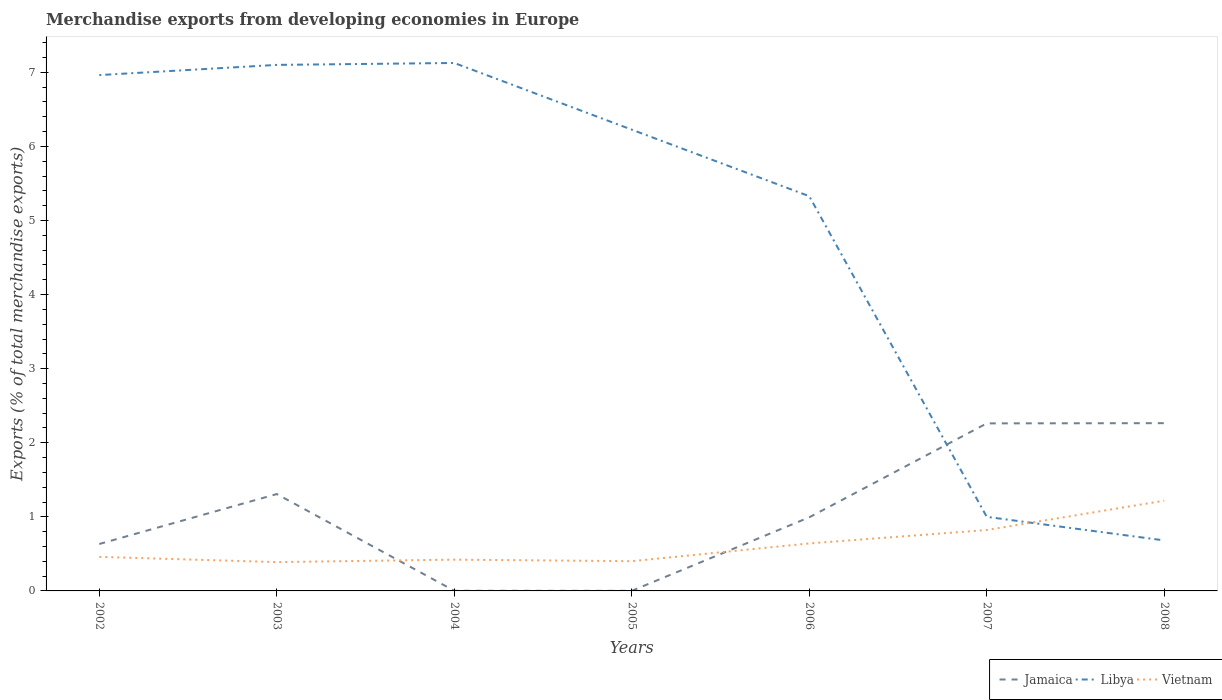How many different coloured lines are there?
Offer a terse response. 3. Does the line corresponding to Jamaica intersect with the line corresponding to Vietnam?
Make the answer very short. Yes. Is the number of lines equal to the number of legend labels?
Your answer should be compact. Yes. Across all years, what is the maximum percentage of total merchandise exports in Jamaica?
Your response must be concise. 0. What is the total percentage of total merchandise exports in Vietnam in the graph?
Your answer should be very brief. -0.18. What is the difference between the highest and the second highest percentage of total merchandise exports in Libya?
Provide a succinct answer. 6.44. Is the percentage of total merchandise exports in Vietnam strictly greater than the percentage of total merchandise exports in Jamaica over the years?
Offer a very short reply. No. How many years are there in the graph?
Provide a short and direct response. 7. What is the difference between two consecutive major ticks on the Y-axis?
Your response must be concise. 1. Does the graph contain any zero values?
Ensure brevity in your answer.  No. How many legend labels are there?
Keep it short and to the point. 3. How are the legend labels stacked?
Your response must be concise. Horizontal. What is the title of the graph?
Your answer should be very brief. Merchandise exports from developing economies in Europe. Does "Uganda" appear as one of the legend labels in the graph?
Your response must be concise. No. What is the label or title of the X-axis?
Offer a very short reply. Years. What is the label or title of the Y-axis?
Offer a terse response. Exports (% of total merchandise exports). What is the Exports (% of total merchandise exports) of Jamaica in 2002?
Provide a short and direct response. 0.63. What is the Exports (% of total merchandise exports) of Libya in 2002?
Your answer should be very brief. 6.96. What is the Exports (% of total merchandise exports) of Vietnam in 2002?
Offer a very short reply. 0.46. What is the Exports (% of total merchandise exports) of Jamaica in 2003?
Ensure brevity in your answer.  1.31. What is the Exports (% of total merchandise exports) in Libya in 2003?
Offer a very short reply. 7.1. What is the Exports (% of total merchandise exports) of Vietnam in 2003?
Offer a very short reply. 0.39. What is the Exports (% of total merchandise exports) of Jamaica in 2004?
Provide a short and direct response. 0. What is the Exports (% of total merchandise exports) of Libya in 2004?
Provide a succinct answer. 7.13. What is the Exports (% of total merchandise exports) in Vietnam in 2004?
Provide a short and direct response. 0.42. What is the Exports (% of total merchandise exports) of Jamaica in 2005?
Give a very brief answer. 0. What is the Exports (% of total merchandise exports) of Libya in 2005?
Make the answer very short. 6.23. What is the Exports (% of total merchandise exports) of Vietnam in 2005?
Provide a short and direct response. 0.4. What is the Exports (% of total merchandise exports) in Jamaica in 2006?
Offer a terse response. 0.99. What is the Exports (% of total merchandise exports) of Libya in 2006?
Offer a terse response. 5.33. What is the Exports (% of total merchandise exports) in Vietnam in 2006?
Your answer should be compact. 0.64. What is the Exports (% of total merchandise exports) in Jamaica in 2007?
Offer a very short reply. 2.26. What is the Exports (% of total merchandise exports) of Libya in 2007?
Give a very brief answer. 1. What is the Exports (% of total merchandise exports) in Vietnam in 2007?
Offer a very short reply. 0.82. What is the Exports (% of total merchandise exports) of Jamaica in 2008?
Make the answer very short. 2.26. What is the Exports (% of total merchandise exports) in Libya in 2008?
Make the answer very short. 0.68. What is the Exports (% of total merchandise exports) in Vietnam in 2008?
Make the answer very short. 1.22. Across all years, what is the maximum Exports (% of total merchandise exports) in Jamaica?
Your response must be concise. 2.26. Across all years, what is the maximum Exports (% of total merchandise exports) in Libya?
Give a very brief answer. 7.13. Across all years, what is the maximum Exports (% of total merchandise exports) of Vietnam?
Provide a succinct answer. 1.22. Across all years, what is the minimum Exports (% of total merchandise exports) of Jamaica?
Keep it short and to the point. 0. Across all years, what is the minimum Exports (% of total merchandise exports) of Libya?
Your answer should be compact. 0.68. Across all years, what is the minimum Exports (% of total merchandise exports) in Vietnam?
Ensure brevity in your answer.  0.39. What is the total Exports (% of total merchandise exports) of Jamaica in the graph?
Offer a very short reply. 7.46. What is the total Exports (% of total merchandise exports) in Libya in the graph?
Keep it short and to the point. 34.42. What is the total Exports (% of total merchandise exports) of Vietnam in the graph?
Your answer should be compact. 4.35. What is the difference between the Exports (% of total merchandise exports) in Jamaica in 2002 and that in 2003?
Give a very brief answer. -0.67. What is the difference between the Exports (% of total merchandise exports) of Libya in 2002 and that in 2003?
Offer a terse response. -0.14. What is the difference between the Exports (% of total merchandise exports) in Vietnam in 2002 and that in 2003?
Provide a succinct answer. 0.07. What is the difference between the Exports (% of total merchandise exports) of Jamaica in 2002 and that in 2004?
Your response must be concise. 0.63. What is the difference between the Exports (% of total merchandise exports) of Libya in 2002 and that in 2004?
Your answer should be very brief. -0.16. What is the difference between the Exports (% of total merchandise exports) in Vietnam in 2002 and that in 2004?
Make the answer very short. 0.04. What is the difference between the Exports (% of total merchandise exports) in Jamaica in 2002 and that in 2005?
Your answer should be very brief. 0.63. What is the difference between the Exports (% of total merchandise exports) in Libya in 2002 and that in 2005?
Ensure brevity in your answer.  0.74. What is the difference between the Exports (% of total merchandise exports) in Vietnam in 2002 and that in 2005?
Provide a succinct answer. 0.06. What is the difference between the Exports (% of total merchandise exports) of Jamaica in 2002 and that in 2006?
Your answer should be very brief. -0.36. What is the difference between the Exports (% of total merchandise exports) in Libya in 2002 and that in 2006?
Offer a very short reply. 1.63. What is the difference between the Exports (% of total merchandise exports) in Vietnam in 2002 and that in 2006?
Your response must be concise. -0.18. What is the difference between the Exports (% of total merchandise exports) of Jamaica in 2002 and that in 2007?
Keep it short and to the point. -1.63. What is the difference between the Exports (% of total merchandise exports) of Libya in 2002 and that in 2007?
Give a very brief answer. 5.96. What is the difference between the Exports (% of total merchandise exports) in Vietnam in 2002 and that in 2007?
Offer a very short reply. -0.36. What is the difference between the Exports (% of total merchandise exports) of Jamaica in 2002 and that in 2008?
Keep it short and to the point. -1.63. What is the difference between the Exports (% of total merchandise exports) in Libya in 2002 and that in 2008?
Offer a terse response. 6.28. What is the difference between the Exports (% of total merchandise exports) of Vietnam in 2002 and that in 2008?
Ensure brevity in your answer.  -0.76. What is the difference between the Exports (% of total merchandise exports) of Jamaica in 2003 and that in 2004?
Your answer should be compact. 1.31. What is the difference between the Exports (% of total merchandise exports) of Libya in 2003 and that in 2004?
Provide a short and direct response. -0.03. What is the difference between the Exports (% of total merchandise exports) in Vietnam in 2003 and that in 2004?
Offer a terse response. -0.03. What is the difference between the Exports (% of total merchandise exports) of Jamaica in 2003 and that in 2005?
Provide a succinct answer. 1.31. What is the difference between the Exports (% of total merchandise exports) of Libya in 2003 and that in 2005?
Make the answer very short. 0.87. What is the difference between the Exports (% of total merchandise exports) in Vietnam in 2003 and that in 2005?
Provide a short and direct response. -0.01. What is the difference between the Exports (% of total merchandise exports) of Jamaica in 2003 and that in 2006?
Offer a very short reply. 0.31. What is the difference between the Exports (% of total merchandise exports) of Libya in 2003 and that in 2006?
Your answer should be very brief. 1.77. What is the difference between the Exports (% of total merchandise exports) of Vietnam in 2003 and that in 2006?
Keep it short and to the point. -0.25. What is the difference between the Exports (% of total merchandise exports) in Jamaica in 2003 and that in 2007?
Offer a very short reply. -0.95. What is the difference between the Exports (% of total merchandise exports) of Libya in 2003 and that in 2007?
Make the answer very short. 6.1. What is the difference between the Exports (% of total merchandise exports) of Vietnam in 2003 and that in 2007?
Give a very brief answer. -0.43. What is the difference between the Exports (% of total merchandise exports) in Jamaica in 2003 and that in 2008?
Your answer should be compact. -0.96. What is the difference between the Exports (% of total merchandise exports) in Libya in 2003 and that in 2008?
Keep it short and to the point. 6.42. What is the difference between the Exports (% of total merchandise exports) of Vietnam in 2003 and that in 2008?
Your answer should be very brief. -0.83. What is the difference between the Exports (% of total merchandise exports) of Jamaica in 2004 and that in 2005?
Your response must be concise. 0. What is the difference between the Exports (% of total merchandise exports) of Libya in 2004 and that in 2005?
Keep it short and to the point. 0.9. What is the difference between the Exports (% of total merchandise exports) in Vietnam in 2004 and that in 2005?
Keep it short and to the point. 0.02. What is the difference between the Exports (% of total merchandise exports) of Jamaica in 2004 and that in 2006?
Ensure brevity in your answer.  -0.99. What is the difference between the Exports (% of total merchandise exports) of Libya in 2004 and that in 2006?
Offer a very short reply. 1.8. What is the difference between the Exports (% of total merchandise exports) of Vietnam in 2004 and that in 2006?
Keep it short and to the point. -0.22. What is the difference between the Exports (% of total merchandise exports) of Jamaica in 2004 and that in 2007?
Your answer should be compact. -2.26. What is the difference between the Exports (% of total merchandise exports) of Libya in 2004 and that in 2007?
Provide a succinct answer. 6.13. What is the difference between the Exports (% of total merchandise exports) in Vietnam in 2004 and that in 2007?
Your answer should be compact. -0.4. What is the difference between the Exports (% of total merchandise exports) in Jamaica in 2004 and that in 2008?
Give a very brief answer. -2.26. What is the difference between the Exports (% of total merchandise exports) in Libya in 2004 and that in 2008?
Your response must be concise. 6.44. What is the difference between the Exports (% of total merchandise exports) in Vietnam in 2004 and that in 2008?
Offer a terse response. -0.8. What is the difference between the Exports (% of total merchandise exports) of Jamaica in 2005 and that in 2006?
Make the answer very short. -0.99. What is the difference between the Exports (% of total merchandise exports) of Libya in 2005 and that in 2006?
Provide a short and direct response. 0.9. What is the difference between the Exports (% of total merchandise exports) of Vietnam in 2005 and that in 2006?
Keep it short and to the point. -0.24. What is the difference between the Exports (% of total merchandise exports) of Jamaica in 2005 and that in 2007?
Make the answer very short. -2.26. What is the difference between the Exports (% of total merchandise exports) in Libya in 2005 and that in 2007?
Provide a succinct answer. 5.23. What is the difference between the Exports (% of total merchandise exports) in Vietnam in 2005 and that in 2007?
Give a very brief answer. -0.42. What is the difference between the Exports (% of total merchandise exports) in Jamaica in 2005 and that in 2008?
Your answer should be compact. -2.26. What is the difference between the Exports (% of total merchandise exports) in Libya in 2005 and that in 2008?
Ensure brevity in your answer.  5.54. What is the difference between the Exports (% of total merchandise exports) of Vietnam in 2005 and that in 2008?
Provide a succinct answer. -0.82. What is the difference between the Exports (% of total merchandise exports) of Jamaica in 2006 and that in 2007?
Offer a very short reply. -1.27. What is the difference between the Exports (% of total merchandise exports) in Libya in 2006 and that in 2007?
Your answer should be compact. 4.33. What is the difference between the Exports (% of total merchandise exports) in Vietnam in 2006 and that in 2007?
Offer a terse response. -0.18. What is the difference between the Exports (% of total merchandise exports) of Jamaica in 2006 and that in 2008?
Provide a succinct answer. -1.27. What is the difference between the Exports (% of total merchandise exports) of Libya in 2006 and that in 2008?
Keep it short and to the point. 4.65. What is the difference between the Exports (% of total merchandise exports) of Vietnam in 2006 and that in 2008?
Offer a very short reply. -0.58. What is the difference between the Exports (% of total merchandise exports) of Jamaica in 2007 and that in 2008?
Ensure brevity in your answer.  -0. What is the difference between the Exports (% of total merchandise exports) of Libya in 2007 and that in 2008?
Give a very brief answer. 0.32. What is the difference between the Exports (% of total merchandise exports) of Vietnam in 2007 and that in 2008?
Ensure brevity in your answer.  -0.4. What is the difference between the Exports (% of total merchandise exports) of Jamaica in 2002 and the Exports (% of total merchandise exports) of Libya in 2003?
Offer a terse response. -6.47. What is the difference between the Exports (% of total merchandise exports) of Jamaica in 2002 and the Exports (% of total merchandise exports) of Vietnam in 2003?
Your response must be concise. 0.24. What is the difference between the Exports (% of total merchandise exports) in Libya in 2002 and the Exports (% of total merchandise exports) in Vietnam in 2003?
Ensure brevity in your answer.  6.57. What is the difference between the Exports (% of total merchandise exports) of Jamaica in 2002 and the Exports (% of total merchandise exports) of Libya in 2004?
Give a very brief answer. -6.49. What is the difference between the Exports (% of total merchandise exports) in Jamaica in 2002 and the Exports (% of total merchandise exports) in Vietnam in 2004?
Your answer should be compact. 0.21. What is the difference between the Exports (% of total merchandise exports) in Libya in 2002 and the Exports (% of total merchandise exports) in Vietnam in 2004?
Provide a succinct answer. 6.54. What is the difference between the Exports (% of total merchandise exports) in Jamaica in 2002 and the Exports (% of total merchandise exports) in Libya in 2005?
Offer a terse response. -5.59. What is the difference between the Exports (% of total merchandise exports) of Jamaica in 2002 and the Exports (% of total merchandise exports) of Vietnam in 2005?
Provide a succinct answer. 0.23. What is the difference between the Exports (% of total merchandise exports) of Libya in 2002 and the Exports (% of total merchandise exports) of Vietnam in 2005?
Provide a succinct answer. 6.56. What is the difference between the Exports (% of total merchandise exports) of Jamaica in 2002 and the Exports (% of total merchandise exports) of Libya in 2006?
Keep it short and to the point. -4.69. What is the difference between the Exports (% of total merchandise exports) of Jamaica in 2002 and the Exports (% of total merchandise exports) of Vietnam in 2006?
Your answer should be compact. -0.01. What is the difference between the Exports (% of total merchandise exports) in Libya in 2002 and the Exports (% of total merchandise exports) in Vietnam in 2006?
Keep it short and to the point. 6.32. What is the difference between the Exports (% of total merchandise exports) in Jamaica in 2002 and the Exports (% of total merchandise exports) in Libya in 2007?
Provide a succinct answer. -0.37. What is the difference between the Exports (% of total merchandise exports) in Jamaica in 2002 and the Exports (% of total merchandise exports) in Vietnam in 2007?
Your response must be concise. -0.19. What is the difference between the Exports (% of total merchandise exports) in Libya in 2002 and the Exports (% of total merchandise exports) in Vietnam in 2007?
Offer a very short reply. 6.14. What is the difference between the Exports (% of total merchandise exports) of Jamaica in 2002 and the Exports (% of total merchandise exports) of Libya in 2008?
Ensure brevity in your answer.  -0.05. What is the difference between the Exports (% of total merchandise exports) of Jamaica in 2002 and the Exports (% of total merchandise exports) of Vietnam in 2008?
Offer a very short reply. -0.58. What is the difference between the Exports (% of total merchandise exports) in Libya in 2002 and the Exports (% of total merchandise exports) in Vietnam in 2008?
Ensure brevity in your answer.  5.74. What is the difference between the Exports (% of total merchandise exports) in Jamaica in 2003 and the Exports (% of total merchandise exports) in Libya in 2004?
Ensure brevity in your answer.  -5.82. What is the difference between the Exports (% of total merchandise exports) in Jamaica in 2003 and the Exports (% of total merchandise exports) in Vietnam in 2004?
Provide a succinct answer. 0.89. What is the difference between the Exports (% of total merchandise exports) of Libya in 2003 and the Exports (% of total merchandise exports) of Vietnam in 2004?
Provide a short and direct response. 6.68. What is the difference between the Exports (% of total merchandise exports) in Jamaica in 2003 and the Exports (% of total merchandise exports) in Libya in 2005?
Provide a short and direct response. -4.92. What is the difference between the Exports (% of total merchandise exports) in Jamaica in 2003 and the Exports (% of total merchandise exports) in Vietnam in 2005?
Your response must be concise. 0.91. What is the difference between the Exports (% of total merchandise exports) of Libya in 2003 and the Exports (% of total merchandise exports) of Vietnam in 2005?
Your answer should be compact. 6.7. What is the difference between the Exports (% of total merchandise exports) in Jamaica in 2003 and the Exports (% of total merchandise exports) in Libya in 2006?
Provide a short and direct response. -4.02. What is the difference between the Exports (% of total merchandise exports) of Jamaica in 2003 and the Exports (% of total merchandise exports) of Vietnam in 2006?
Provide a succinct answer. 0.67. What is the difference between the Exports (% of total merchandise exports) of Libya in 2003 and the Exports (% of total merchandise exports) of Vietnam in 2006?
Keep it short and to the point. 6.46. What is the difference between the Exports (% of total merchandise exports) of Jamaica in 2003 and the Exports (% of total merchandise exports) of Libya in 2007?
Your answer should be compact. 0.31. What is the difference between the Exports (% of total merchandise exports) of Jamaica in 2003 and the Exports (% of total merchandise exports) of Vietnam in 2007?
Your response must be concise. 0.49. What is the difference between the Exports (% of total merchandise exports) in Libya in 2003 and the Exports (% of total merchandise exports) in Vietnam in 2007?
Ensure brevity in your answer.  6.28. What is the difference between the Exports (% of total merchandise exports) of Jamaica in 2003 and the Exports (% of total merchandise exports) of Libya in 2008?
Make the answer very short. 0.63. What is the difference between the Exports (% of total merchandise exports) in Jamaica in 2003 and the Exports (% of total merchandise exports) in Vietnam in 2008?
Give a very brief answer. 0.09. What is the difference between the Exports (% of total merchandise exports) of Libya in 2003 and the Exports (% of total merchandise exports) of Vietnam in 2008?
Ensure brevity in your answer.  5.88. What is the difference between the Exports (% of total merchandise exports) in Jamaica in 2004 and the Exports (% of total merchandise exports) in Libya in 2005?
Offer a very short reply. -6.22. What is the difference between the Exports (% of total merchandise exports) in Jamaica in 2004 and the Exports (% of total merchandise exports) in Vietnam in 2005?
Offer a terse response. -0.4. What is the difference between the Exports (% of total merchandise exports) in Libya in 2004 and the Exports (% of total merchandise exports) in Vietnam in 2005?
Provide a short and direct response. 6.72. What is the difference between the Exports (% of total merchandise exports) of Jamaica in 2004 and the Exports (% of total merchandise exports) of Libya in 2006?
Offer a terse response. -5.33. What is the difference between the Exports (% of total merchandise exports) in Jamaica in 2004 and the Exports (% of total merchandise exports) in Vietnam in 2006?
Offer a terse response. -0.64. What is the difference between the Exports (% of total merchandise exports) in Libya in 2004 and the Exports (% of total merchandise exports) in Vietnam in 2006?
Offer a very short reply. 6.48. What is the difference between the Exports (% of total merchandise exports) in Jamaica in 2004 and the Exports (% of total merchandise exports) in Libya in 2007?
Make the answer very short. -1. What is the difference between the Exports (% of total merchandise exports) of Jamaica in 2004 and the Exports (% of total merchandise exports) of Vietnam in 2007?
Your answer should be very brief. -0.82. What is the difference between the Exports (% of total merchandise exports) of Libya in 2004 and the Exports (% of total merchandise exports) of Vietnam in 2007?
Provide a short and direct response. 6.3. What is the difference between the Exports (% of total merchandise exports) in Jamaica in 2004 and the Exports (% of total merchandise exports) in Libya in 2008?
Offer a terse response. -0.68. What is the difference between the Exports (% of total merchandise exports) in Jamaica in 2004 and the Exports (% of total merchandise exports) in Vietnam in 2008?
Ensure brevity in your answer.  -1.22. What is the difference between the Exports (% of total merchandise exports) in Libya in 2004 and the Exports (% of total merchandise exports) in Vietnam in 2008?
Make the answer very short. 5.91. What is the difference between the Exports (% of total merchandise exports) of Jamaica in 2005 and the Exports (% of total merchandise exports) of Libya in 2006?
Offer a terse response. -5.33. What is the difference between the Exports (% of total merchandise exports) in Jamaica in 2005 and the Exports (% of total merchandise exports) in Vietnam in 2006?
Ensure brevity in your answer.  -0.64. What is the difference between the Exports (% of total merchandise exports) in Libya in 2005 and the Exports (% of total merchandise exports) in Vietnam in 2006?
Offer a very short reply. 5.58. What is the difference between the Exports (% of total merchandise exports) in Jamaica in 2005 and the Exports (% of total merchandise exports) in Libya in 2007?
Keep it short and to the point. -1. What is the difference between the Exports (% of total merchandise exports) of Jamaica in 2005 and the Exports (% of total merchandise exports) of Vietnam in 2007?
Your answer should be very brief. -0.82. What is the difference between the Exports (% of total merchandise exports) of Libya in 2005 and the Exports (% of total merchandise exports) of Vietnam in 2007?
Give a very brief answer. 5.4. What is the difference between the Exports (% of total merchandise exports) of Jamaica in 2005 and the Exports (% of total merchandise exports) of Libya in 2008?
Offer a very short reply. -0.68. What is the difference between the Exports (% of total merchandise exports) of Jamaica in 2005 and the Exports (% of total merchandise exports) of Vietnam in 2008?
Provide a succinct answer. -1.22. What is the difference between the Exports (% of total merchandise exports) in Libya in 2005 and the Exports (% of total merchandise exports) in Vietnam in 2008?
Make the answer very short. 5.01. What is the difference between the Exports (% of total merchandise exports) of Jamaica in 2006 and the Exports (% of total merchandise exports) of Libya in 2007?
Your answer should be very brief. -0.01. What is the difference between the Exports (% of total merchandise exports) of Jamaica in 2006 and the Exports (% of total merchandise exports) of Vietnam in 2007?
Make the answer very short. 0.17. What is the difference between the Exports (% of total merchandise exports) of Libya in 2006 and the Exports (% of total merchandise exports) of Vietnam in 2007?
Ensure brevity in your answer.  4.51. What is the difference between the Exports (% of total merchandise exports) of Jamaica in 2006 and the Exports (% of total merchandise exports) of Libya in 2008?
Keep it short and to the point. 0.31. What is the difference between the Exports (% of total merchandise exports) of Jamaica in 2006 and the Exports (% of total merchandise exports) of Vietnam in 2008?
Your answer should be very brief. -0.22. What is the difference between the Exports (% of total merchandise exports) in Libya in 2006 and the Exports (% of total merchandise exports) in Vietnam in 2008?
Keep it short and to the point. 4.11. What is the difference between the Exports (% of total merchandise exports) in Jamaica in 2007 and the Exports (% of total merchandise exports) in Libya in 2008?
Your answer should be very brief. 1.58. What is the difference between the Exports (% of total merchandise exports) in Jamaica in 2007 and the Exports (% of total merchandise exports) in Vietnam in 2008?
Offer a very short reply. 1.04. What is the difference between the Exports (% of total merchandise exports) of Libya in 2007 and the Exports (% of total merchandise exports) of Vietnam in 2008?
Make the answer very short. -0.22. What is the average Exports (% of total merchandise exports) of Jamaica per year?
Give a very brief answer. 1.07. What is the average Exports (% of total merchandise exports) in Libya per year?
Provide a short and direct response. 4.92. What is the average Exports (% of total merchandise exports) of Vietnam per year?
Provide a succinct answer. 0.62. In the year 2002, what is the difference between the Exports (% of total merchandise exports) of Jamaica and Exports (% of total merchandise exports) of Libya?
Ensure brevity in your answer.  -6.33. In the year 2002, what is the difference between the Exports (% of total merchandise exports) in Jamaica and Exports (% of total merchandise exports) in Vietnam?
Offer a very short reply. 0.17. In the year 2002, what is the difference between the Exports (% of total merchandise exports) in Libya and Exports (% of total merchandise exports) in Vietnam?
Offer a very short reply. 6.5. In the year 2003, what is the difference between the Exports (% of total merchandise exports) in Jamaica and Exports (% of total merchandise exports) in Libya?
Ensure brevity in your answer.  -5.79. In the year 2003, what is the difference between the Exports (% of total merchandise exports) of Jamaica and Exports (% of total merchandise exports) of Vietnam?
Provide a succinct answer. 0.92. In the year 2003, what is the difference between the Exports (% of total merchandise exports) in Libya and Exports (% of total merchandise exports) in Vietnam?
Offer a terse response. 6.71. In the year 2004, what is the difference between the Exports (% of total merchandise exports) of Jamaica and Exports (% of total merchandise exports) of Libya?
Make the answer very short. -7.12. In the year 2004, what is the difference between the Exports (% of total merchandise exports) of Jamaica and Exports (% of total merchandise exports) of Vietnam?
Provide a short and direct response. -0.42. In the year 2004, what is the difference between the Exports (% of total merchandise exports) of Libya and Exports (% of total merchandise exports) of Vietnam?
Your response must be concise. 6.7. In the year 2005, what is the difference between the Exports (% of total merchandise exports) of Jamaica and Exports (% of total merchandise exports) of Libya?
Offer a very short reply. -6.22. In the year 2005, what is the difference between the Exports (% of total merchandise exports) in Libya and Exports (% of total merchandise exports) in Vietnam?
Keep it short and to the point. 5.82. In the year 2006, what is the difference between the Exports (% of total merchandise exports) in Jamaica and Exports (% of total merchandise exports) in Libya?
Offer a very short reply. -4.33. In the year 2006, what is the difference between the Exports (% of total merchandise exports) of Jamaica and Exports (% of total merchandise exports) of Vietnam?
Ensure brevity in your answer.  0.35. In the year 2006, what is the difference between the Exports (% of total merchandise exports) of Libya and Exports (% of total merchandise exports) of Vietnam?
Your answer should be very brief. 4.69. In the year 2007, what is the difference between the Exports (% of total merchandise exports) in Jamaica and Exports (% of total merchandise exports) in Libya?
Your answer should be very brief. 1.26. In the year 2007, what is the difference between the Exports (% of total merchandise exports) in Jamaica and Exports (% of total merchandise exports) in Vietnam?
Offer a terse response. 1.44. In the year 2007, what is the difference between the Exports (% of total merchandise exports) of Libya and Exports (% of total merchandise exports) of Vietnam?
Your answer should be very brief. 0.18. In the year 2008, what is the difference between the Exports (% of total merchandise exports) in Jamaica and Exports (% of total merchandise exports) in Libya?
Provide a succinct answer. 1.58. In the year 2008, what is the difference between the Exports (% of total merchandise exports) in Jamaica and Exports (% of total merchandise exports) in Vietnam?
Make the answer very short. 1.05. In the year 2008, what is the difference between the Exports (% of total merchandise exports) of Libya and Exports (% of total merchandise exports) of Vietnam?
Your answer should be compact. -0.54. What is the ratio of the Exports (% of total merchandise exports) in Jamaica in 2002 to that in 2003?
Make the answer very short. 0.48. What is the ratio of the Exports (% of total merchandise exports) of Libya in 2002 to that in 2003?
Offer a very short reply. 0.98. What is the ratio of the Exports (% of total merchandise exports) in Vietnam in 2002 to that in 2003?
Make the answer very short. 1.18. What is the ratio of the Exports (% of total merchandise exports) of Jamaica in 2002 to that in 2004?
Ensure brevity in your answer.  344.16. What is the ratio of the Exports (% of total merchandise exports) in Libya in 2002 to that in 2004?
Keep it short and to the point. 0.98. What is the ratio of the Exports (% of total merchandise exports) of Vietnam in 2002 to that in 2004?
Your answer should be compact. 1.09. What is the ratio of the Exports (% of total merchandise exports) of Jamaica in 2002 to that in 2005?
Ensure brevity in your answer.  511.08. What is the ratio of the Exports (% of total merchandise exports) of Libya in 2002 to that in 2005?
Provide a short and direct response. 1.12. What is the ratio of the Exports (% of total merchandise exports) of Vietnam in 2002 to that in 2005?
Make the answer very short. 1.15. What is the ratio of the Exports (% of total merchandise exports) in Jamaica in 2002 to that in 2006?
Ensure brevity in your answer.  0.64. What is the ratio of the Exports (% of total merchandise exports) of Libya in 2002 to that in 2006?
Your answer should be compact. 1.31. What is the ratio of the Exports (% of total merchandise exports) in Vietnam in 2002 to that in 2006?
Your answer should be very brief. 0.72. What is the ratio of the Exports (% of total merchandise exports) in Jamaica in 2002 to that in 2007?
Provide a short and direct response. 0.28. What is the ratio of the Exports (% of total merchandise exports) of Libya in 2002 to that in 2007?
Keep it short and to the point. 6.96. What is the ratio of the Exports (% of total merchandise exports) in Vietnam in 2002 to that in 2007?
Offer a terse response. 0.56. What is the ratio of the Exports (% of total merchandise exports) of Jamaica in 2002 to that in 2008?
Your answer should be very brief. 0.28. What is the ratio of the Exports (% of total merchandise exports) of Libya in 2002 to that in 2008?
Your response must be concise. 10.21. What is the ratio of the Exports (% of total merchandise exports) in Vietnam in 2002 to that in 2008?
Your response must be concise. 0.38. What is the ratio of the Exports (% of total merchandise exports) of Jamaica in 2003 to that in 2004?
Your answer should be compact. 710.58. What is the ratio of the Exports (% of total merchandise exports) in Vietnam in 2003 to that in 2004?
Provide a short and direct response. 0.92. What is the ratio of the Exports (% of total merchandise exports) of Jamaica in 2003 to that in 2005?
Offer a very short reply. 1055.22. What is the ratio of the Exports (% of total merchandise exports) in Libya in 2003 to that in 2005?
Give a very brief answer. 1.14. What is the ratio of the Exports (% of total merchandise exports) in Vietnam in 2003 to that in 2005?
Make the answer very short. 0.97. What is the ratio of the Exports (% of total merchandise exports) of Jamaica in 2003 to that in 2006?
Provide a short and direct response. 1.32. What is the ratio of the Exports (% of total merchandise exports) of Libya in 2003 to that in 2006?
Keep it short and to the point. 1.33. What is the ratio of the Exports (% of total merchandise exports) of Vietnam in 2003 to that in 2006?
Your answer should be compact. 0.61. What is the ratio of the Exports (% of total merchandise exports) of Jamaica in 2003 to that in 2007?
Offer a very short reply. 0.58. What is the ratio of the Exports (% of total merchandise exports) of Libya in 2003 to that in 2007?
Provide a short and direct response. 7.1. What is the ratio of the Exports (% of total merchandise exports) of Vietnam in 2003 to that in 2007?
Give a very brief answer. 0.47. What is the ratio of the Exports (% of total merchandise exports) of Jamaica in 2003 to that in 2008?
Make the answer very short. 0.58. What is the ratio of the Exports (% of total merchandise exports) in Libya in 2003 to that in 2008?
Ensure brevity in your answer.  10.41. What is the ratio of the Exports (% of total merchandise exports) of Vietnam in 2003 to that in 2008?
Offer a very short reply. 0.32. What is the ratio of the Exports (% of total merchandise exports) in Jamaica in 2004 to that in 2005?
Offer a terse response. 1.49. What is the ratio of the Exports (% of total merchandise exports) in Libya in 2004 to that in 2005?
Give a very brief answer. 1.14. What is the ratio of the Exports (% of total merchandise exports) in Vietnam in 2004 to that in 2005?
Offer a very short reply. 1.05. What is the ratio of the Exports (% of total merchandise exports) in Jamaica in 2004 to that in 2006?
Provide a short and direct response. 0. What is the ratio of the Exports (% of total merchandise exports) of Libya in 2004 to that in 2006?
Provide a short and direct response. 1.34. What is the ratio of the Exports (% of total merchandise exports) in Vietnam in 2004 to that in 2006?
Make the answer very short. 0.66. What is the ratio of the Exports (% of total merchandise exports) of Jamaica in 2004 to that in 2007?
Ensure brevity in your answer.  0. What is the ratio of the Exports (% of total merchandise exports) in Libya in 2004 to that in 2007?
Ensure brevity in your answer.  7.13. What is the ratio of the Exports (% of total merchandise exports) in Vietnam in 2004 to that in 2007?
Your answer should be very brief. 0.51. What is the ratio of the Exports (% of total merchandise exports) in Jamaica in 2004 to that in 2008?
Offer a very short reply. 0. What is the ratio of the Exports (% of total merchandise exports) of Libya in 2004 to that in 2008?
Ensure brevity in your answer.  10.45. What is the ratio of the Exports (% of total merchandise exports) in Vietnam in 2004 to that in 2008?
Provide a short and direct response. 0.35. What is the ratio of the Exports (% of total merchandise exports) in Jamaica in 2005 to that in 2006?
Your answer should be very brief. 0. What is the ratio of the Exports (% of total merchandise exports) in Libya in 2005 to that in 2006?
Make the answer very short. 1.17. What is the ratio of the Exports (% of total merchandise exports) in Vietnam in 2005 to that in 2006?
Ensure brevity in your answer.  0.63. What is the ratio of the Exports (% of total merchandise exports) in Libya in 2005 to that in 2007?
Your answer should be compact. 6.23. What is the ratio of the Exports (% of total merchandise exports) of Vietnam in 2005 to that in 2007?
Give a very brief answer. 0.49. What is the ratio of the Exports (% of total merchandise exports) of Jamaica in 2005 to that in 2008?
Offer a very short reply. 0. What is the ratio of the Exports (% of total merchandise exports) of Libya in 2005 to that in 2008?
Ensure brevity in your answer.  9.13. What is the ratio of the Exports (% of total merchandise exports) of Vietnam in 2005 to that in 2008?
Ensure brevity in your answer.  0.33. What is the ratio of the Exports (% of total merchandise exports) in Jamaica in 2006 to that in 2007?
Offer a very short reply. 0.44. What is the ratio of the Exports (% of total merchandise exports) in Libya in 2006 to that in 2007?
Provide a succinct answer. 5.33. What is the ratio of the Exports (% of total merchandise exports) of Vietnam in 2006 to that in 2007?
Make the answer very short. 0.78. What is the ratio of the Exports (% of total merchandise exports) in Jamaica in 2006 to that in 2008?
Provide a succinct answer. 0.44. What is the ratio of the Exports (% of total merchandise exports) of Libya in 2006 to that in 2008?
Make the answer very short. 7.81. What is the ratio of the Exports (% of total merchandise exports) of Vietnam in 2006 to that in 2008?
Keep it short and to the point. 0.53. What is the ratio of the Exports (% of total merchandise exports) in Jamaica in 2007 to that in 2008?
Your response must be concise. 1. What is the ratio of the Exports (% of total merchandise exports) of Libya in 2007 to that in 2008?
Your answer should be compact. 1.47. What is the ratio of the Exports (% of total merchandise exports) in Vietnam in 2007 to that in 2008?
Provide a succinct answer. 0.67. What is the difference between the highest and the second highest Exports (% of total merchandise exports) of Jamaica?
Offer a very short reply. 0. What is the difference between the highest and the second highest Exports (% of total merchandise exports) of Libya?
Offer a very short reply. 0.03. What is the difference between the highest and the second highest Exports (% of total merchandise exports) of Vietnam?
Give a very brief answer. 0.4. What is the difference between the highest and the lowest Exports (% of total merchandise exports) in Jamaica?
Keep it short and to the point. 2.26. What is the difference between the highest and the lowest Exports (% of total merchandise exports) of Libya?
Offer a very short reply. 6.44. What is the difference between the highest and the lowest Exports (% of total merchandise exports) of Vietnam?
Ensure brevity in your answer.  0.83. 